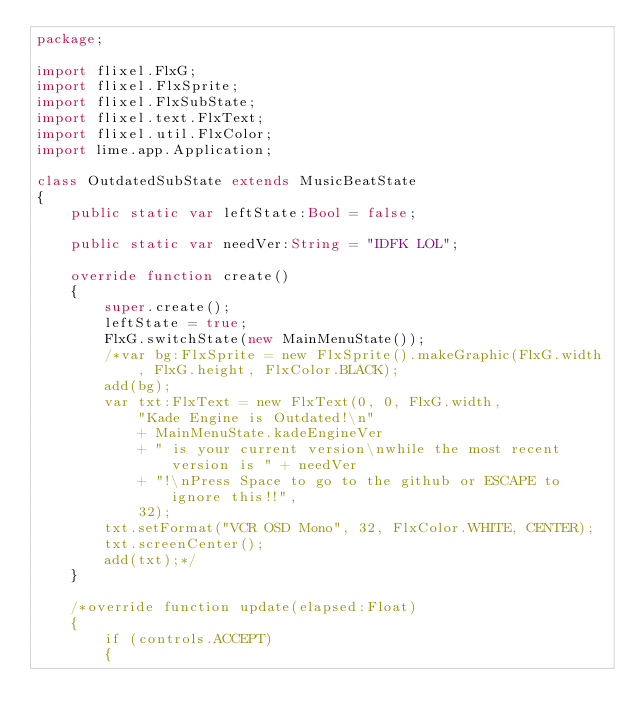Convert code to text. <code><loc_0><loc_0><loc_500><loc_500><_Haxe_>package;

import flixel.FlxG;
import flixel.FlxSprite;
import flixel.FlxSubState;
import flixel.text.FlxText;
import flixel.util.FlxColor;
import lime.app.Application;

class OutdatedSubState extends MusicBeatState
{
	public static var leftState:Bool = false;

	public static var needVer:String = "IDFK LOL";

	override function create()
	{
		super.create();
		leftState = true;
		FlxG.switchState(new MainMenuState());
		/*var bg:FlxSprite = new FlxSprite().makeGraphic(FlxG.width, FlxG.height, FlxColor.BLACK);
		add(bg);
		var txt:FlxText = new FlxText(0, 0, FlxG.width,
			"Kade Engine is Outdated!\n"
			+ MainMenuState.kadeEngineVer
			+ " is your current version\nwhile the most recent version is " + needVer
			+ "!\nPress Space to go to the github or ESCAPE to ignore this!!",
			32);
		txt.setFormat("VCR OSD Mono", 32, FlxColor.WHITE, CENTER);
		txt.screenCenter();
		add(txt);*/
	}

	/*override function update(elapsed:Float)
	{
		if (controls.ACCEPT)
		{</code> 